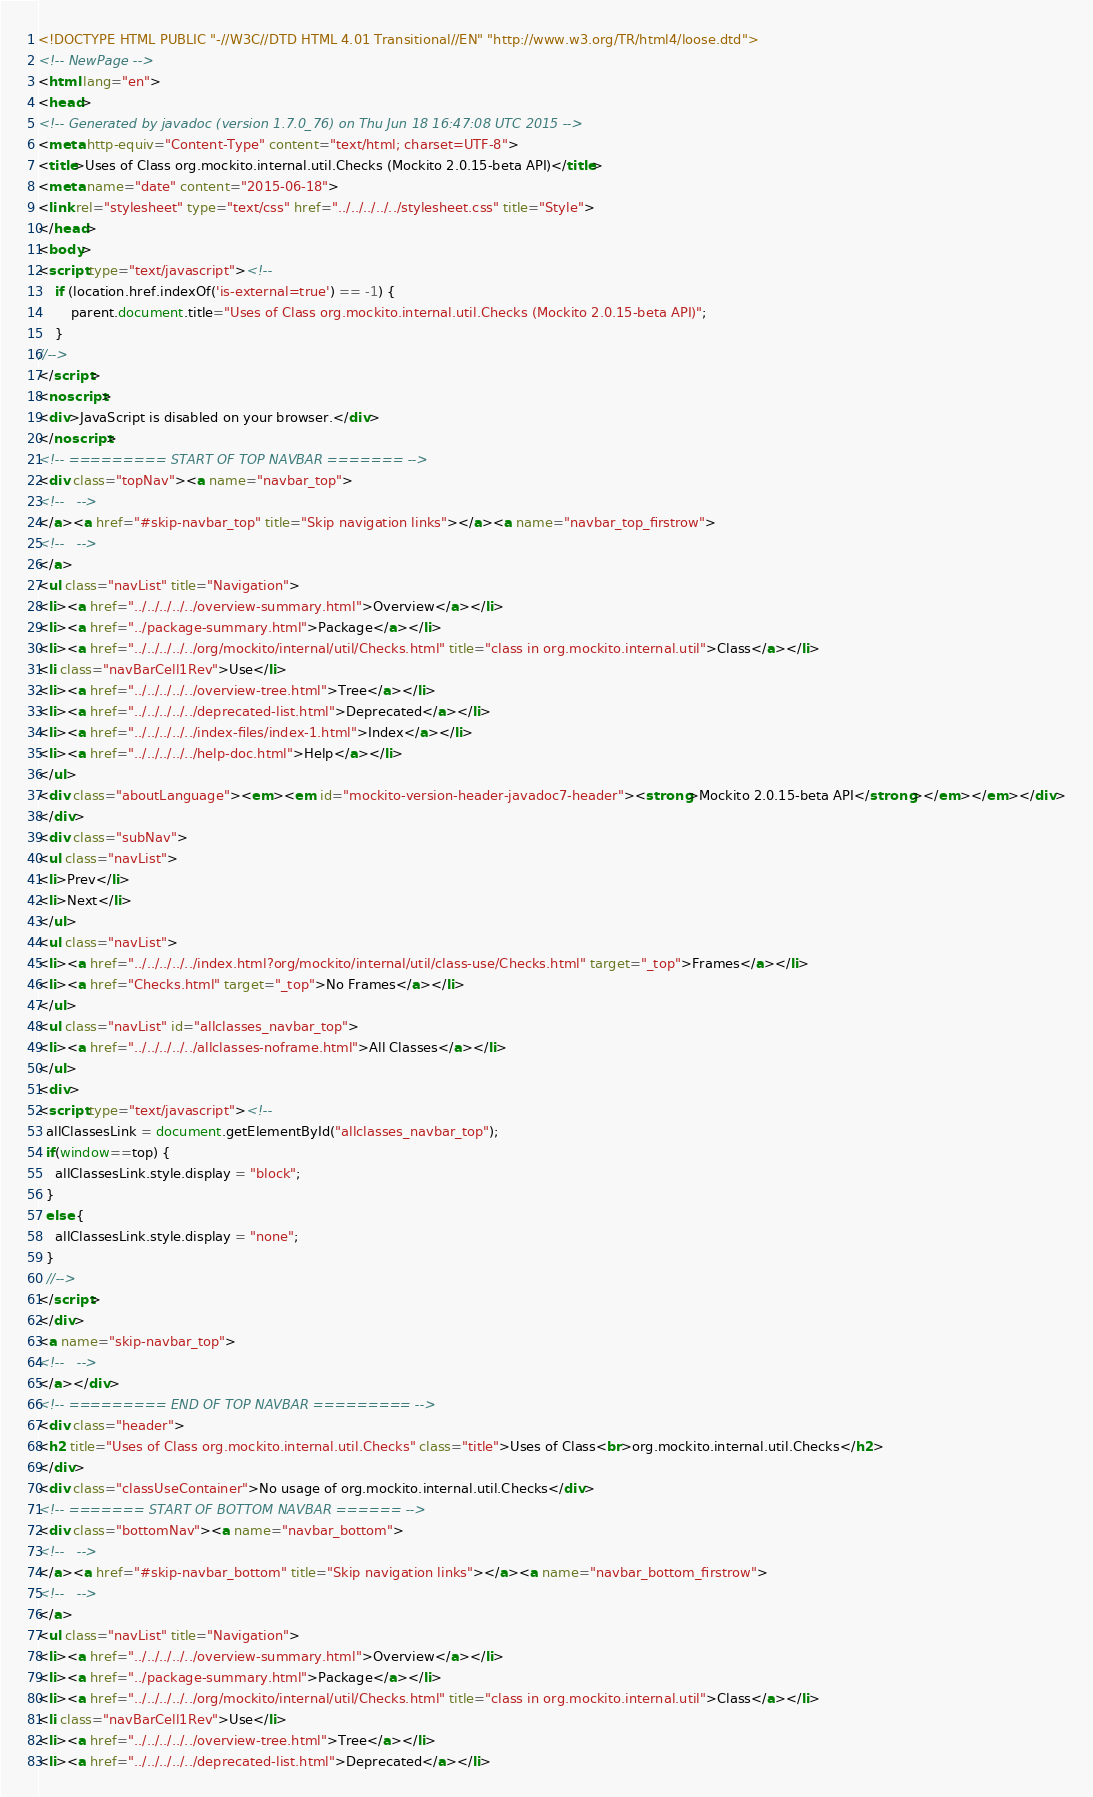Convert code to text. <code><loc_0><loc_0><loc_500><loc_500><_HTML_><!DOCTYPE HTML PUBLIC "-//W3C//DTD HTML 4.01 Transitional//EN" "http://www.w3.org/TR/html4/loose.dtd">
<!-- NewPage -->
<html lang="en">
<head>
<!-- Generated by javadoc (version 1.7.0_76) on Thu Jun 18 16:47:08 UTC 2015 -->
<meta http-equiv="Content-Type" content="text/html; charset=UTF-8">
<title>Uses of Class org.mockito.internal.util.Checks (Mockito 2.0.15-beta API)</title>
<meta name="date" content="2015-06-18">
<link rel="stylesheet" type="text/css" href="../../../../../stylesheet.css" title="Style">
</head>
<body>
<script type="text/javascript"><!--
    if (location.href.indexOf('is-external=true') == -1) {
        parent.document.title="Uses of Class org.mockito.internal.util.Checks (Mockito 2.0.15-beta API)";
    }
//-->
</script>
<noscript>
<div>JavaScript is disabled on your browser.</div>
</noscript>
<!-- ========= START OF TOP NAVBAR ======= -->
<div class="topNav"><a name="navbar_top">
<!--   -->
</a><a href="#skip-navbar_top" title="Skip navigation links"></a><a name="navbar_top_firstrow">
<!--   -->
</a>
<ul class="navList" title="Navigation">
<li><a href="../../../../../overview-summary.html">Overview</a></li>
<li><a href="../package-summary.html">Package</a></li>
<li><a href="../../../../../org/mockito/internal/util/Checks.html" title="class in org.mockito.internal.util">Class</a></li>
<li class="navBarCell1Rev">Use</li>
<li><a href="../../../../../overview-tree.html">Tree</a></li>
<li><a href="../../../../../deprecated-list.html">Deprecated</a></li>
<li><a href="../../../../../index-files/index-1.html">Index</a></li>
<li><a href="../../../../../help-doc.html">Help</a></li>
</ul>
<div class="aboutLanguage"><em><em id="mockito-version-header-javadoc7-header"><strong>Mockito 2.0.15-beta API</strong></em></em></div>
</div>
<div class="subNav">
<ul class="navList">
<li>Prev</li>
<li>Next</li>
</ul>
<ul class="navList">
<li><a href="../../../../../index.html?org/mockito/internal/util/class-use/Checks.html" target="_top">Frames</a></li>
<li><a href="Checks.html" target="_top">No Frames</a></li>
</ul>
<ul class="navList" id="allclasses_navbar_top">
<li><a href="../../../../../allclasses-noframe.html">All Classes</a></li>
</ul>
<div>
<script type="text/javascript"><!--
  allClassesLink = document.getElementById("allclasses_navbar_top");
  if(window==top) {
    allClassesLink.style.display = "block";
  }
  else {
    allClassesLink.style.display = "none";
  }
  //-->
</script>
</div>
<a name="skip-navbar_top">
<!--   -->
</a></div>
<!-- ========= END OF TOP NAVBAR ========= -->
<div class="header">
<h2 title="Uses of Class org.mockito.internal.util.Checks" class="title">Uses of Class<br>org.mockito.internal.util.Checks</h2>
</div>
<div class="classUseContainer">No usage of org.mockito.internal.util.Checks</div>
<!-- ======= START OF BOTTOM NAVBAR ====== -->
<div class="bottomNav"><a name="navbar_bottom">
<!--   -->
</a><a href="#skip-navbar_bottom" title="Skip navigation links"></a><a name="navbar_bottom_firstrow">
<!--   -->
</a>
<ul class="navList" title="Navigation">
<li><a href="../../../../../overview-summary.html">Overview</a></li>
<li><a href="../package-summary.html">Package</a></li>
<li><a href="../../../../../org/mockito/internal/util/Checks.html" title="class in org.mockito.internal.util">Class</a></li>
<li class="navBarCell1Rev">Use</li>
<li><a href="../../../../../overview-tree.html">Tree</a></li>
<li><a href="../../../../../deprecated-list.html">Deprecated</a></li></code> 